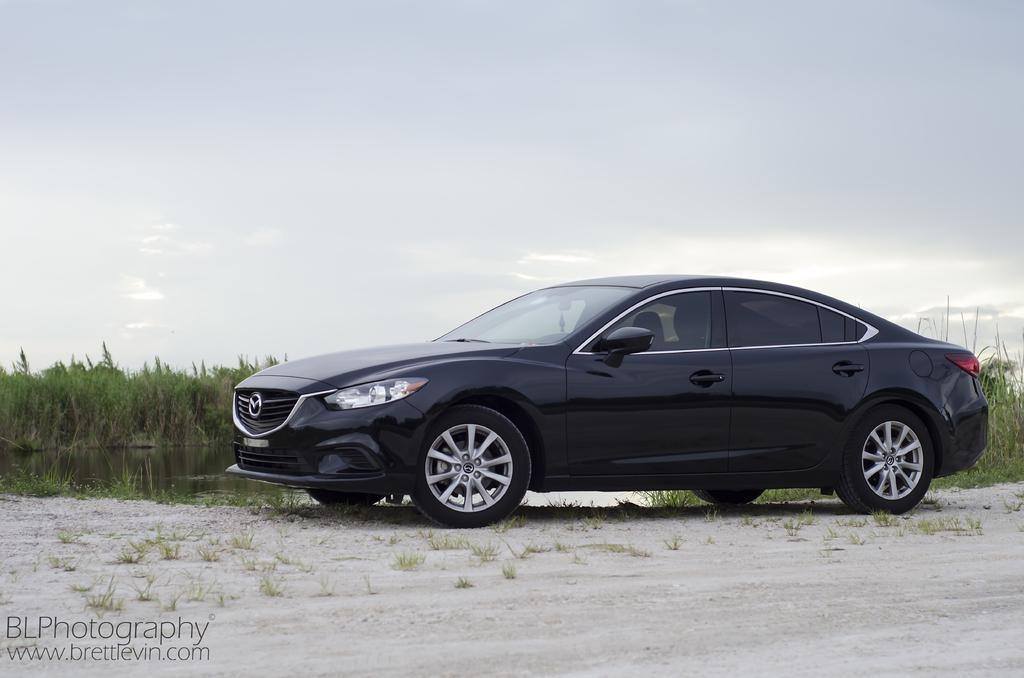What is the main subject of the image? The main subject of the image is a car. What color is the car in the image? The car is black and white in color. Where is the car located in the image? The car is on the ground. What can be seen in the background of the image? Water, plants, grass, and the sky are visible in the background of the image. What type of behavior can be observed in the brothers in the image? There are no brothers present in the image, so it is not possible to observe their behavior. What tool is being used to fix the car in the image? There is no tool visible in the image, and the car does not appear to be in need of repair. 